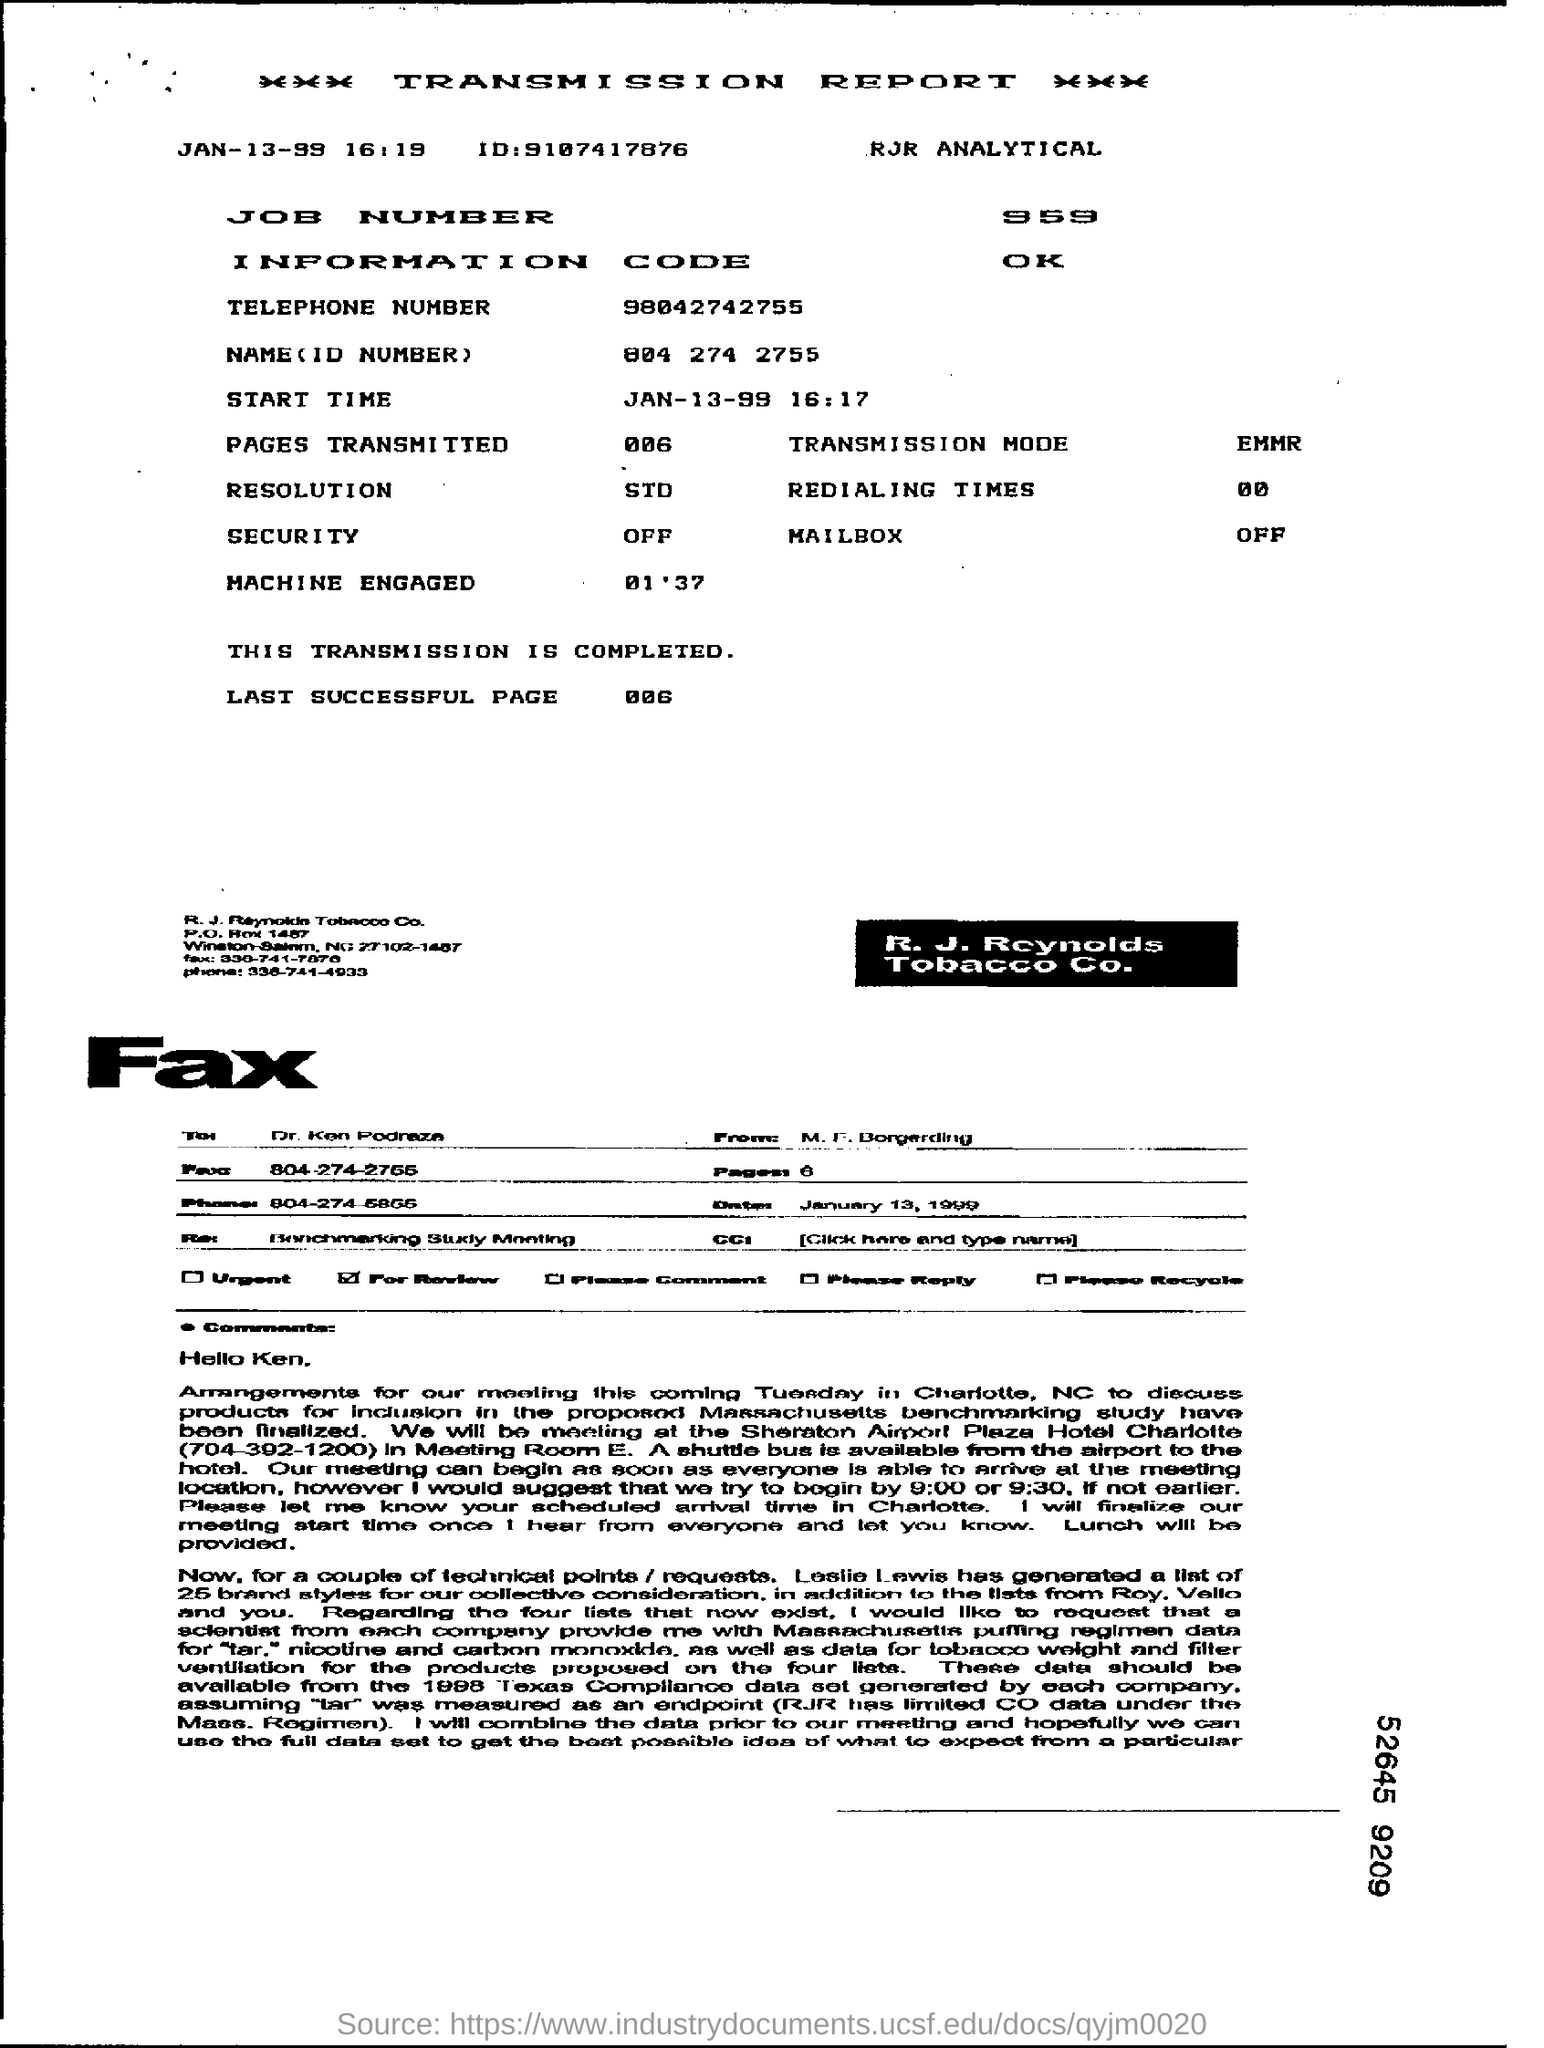What is the status of transmission mentioned in the report?
Your answer should be very brief. Completed. What is the transmission starting time?
Provide a succinct answer. 16:17. What is the job number?
Provide a succinct answer. 959. How many pages are transmitted?
Your response must be concise. 006. 